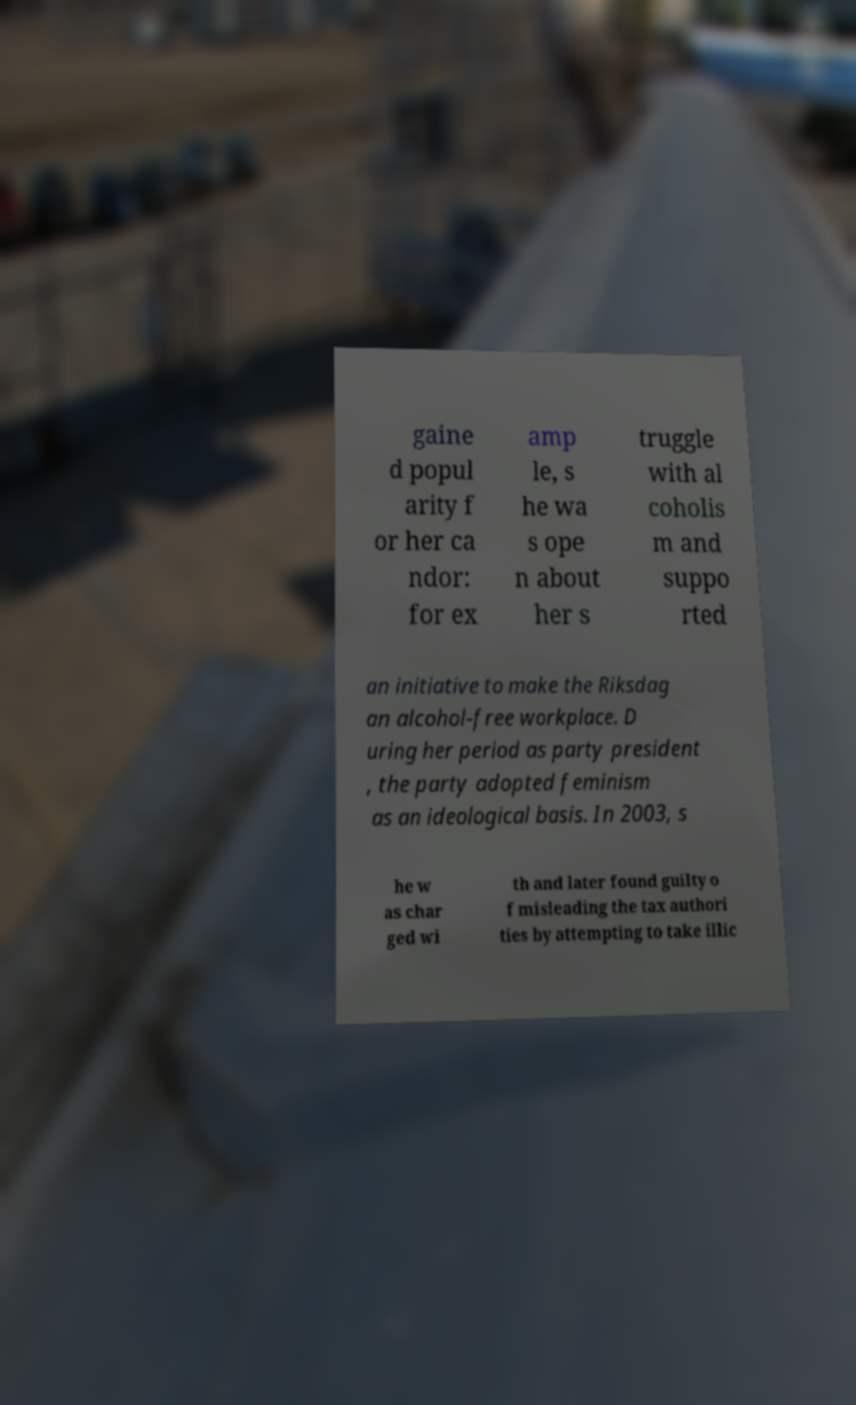Can you read and provide the text displayed in the image?This photo seems to have some interesting text. Can you extract and type it out for me? gaine d popul arity f or her ca ndor: for ex amp le, s he wa s ope n about her s truggle with al coholis m and suppo rted an initiative to make the Riksdag an alcohol-free workplace. D uring her period as party president , the party adopted feminism as an ideological basis. In 2003, s he w as char ged wi th and later found guilty o f misleading the tax authori ties by attempting to take illic 